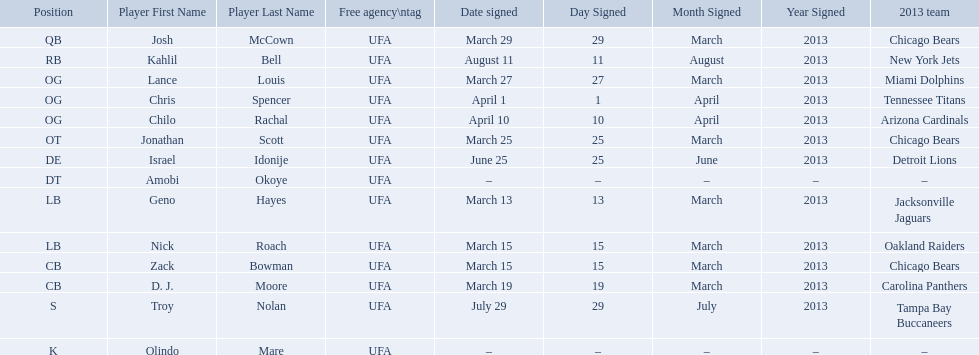Who are all the players on the 2013 chicago bears season team? Josh McCown, Kahlil Bell, Lance Louis, Chris Spencer, Chilo Rachal, Jonathan Scott, Israel Idonije, Amobi Okoye, Geno Hayes, Nick Roach, Zack Bowman, D. J. Moore, Troy Nolan, Olindo Mare. What day was nick roach signed? March 15. What other day matches this? March 15. Who was signed on the day? Zack Bowman. Who are all of the players? Josh McCown, Kahlil Bell, Lance Louis, Chris Spencer, Chilo Rachal, Jonathan Scott, Israel Idonije, Amobi Okoye, Geno Hayes, Nick Roach, Zack Bowman, D. J. Moore, Troy Nolan, Olindo Mare. When were they signed? March 29, August 11, March 27, April 1, April 10, March 25, June 25, –, March 13, March 15, March 15, March 19, July 29, –. Along with nick roach, who else was signed on march 15? Zack Bowman. 